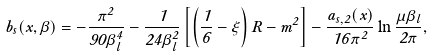<formula> <loc_0><loc_0><loc_500><loc_500>b _ { s } ( x , \beta ) = - { \frac { \pi ^ { 2 } } { 9 0 \beta _ { l } ^ { 4 } } } - { \frac { 1 } { 2 4 \beta _ { l } ^ { 2 } } } \left [ \left ( \frac { 1 } { 6 } - \xi \right ) R - m ^ { 2 } \right ] - { \frac { a _ { s , 2 } ( x ) } { 1 6 \pi ^ { 2 } } } \ln { \frac { \mu \beta _ { l } } { 2 \pi } } ,</formula> 